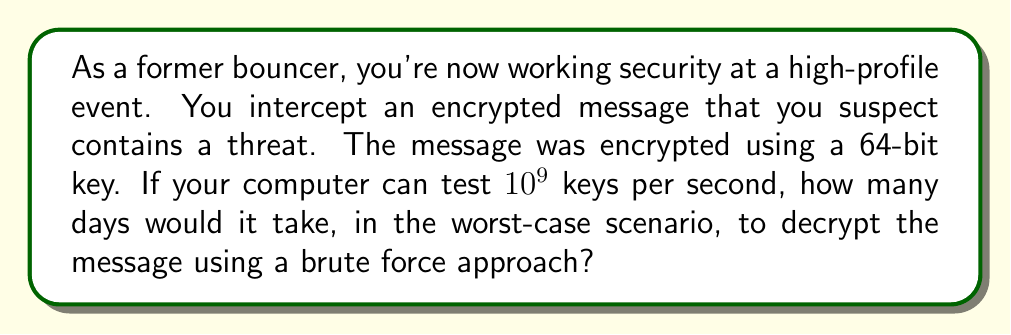Could you help me with this problem? Let's approach this step-by-step:

1) First, we need to calculate the total number of possible keys:
   With a 64-bit key, there are $2^{64}$ possible combinations.

2) Now, let's convert this to a decimal number:
   $2^{64} = 18,446,744,073,709,551,616$

3) We know that the computer can test $10^9$ keys per second.
   So, we need to divide the total number of keys by the keys tested per second:

   $$\frac{18,446,744,073,709,551,616}{10^9} = 18,446,744,073.709551616\text{ seconds}$$

4) To convert this to days, we need to divide by the number of seconds in a day:
   There are 86,400 seconds in a day (24 * 60 * 60).

   $$\frac{18,446,744,073.709551616}{86,400} = 213,503.982\text{ days}$$

5) Rounding up to the nearest whole day (since we're considering the worst-case scenario):
   214 days
Answer: 214 days 